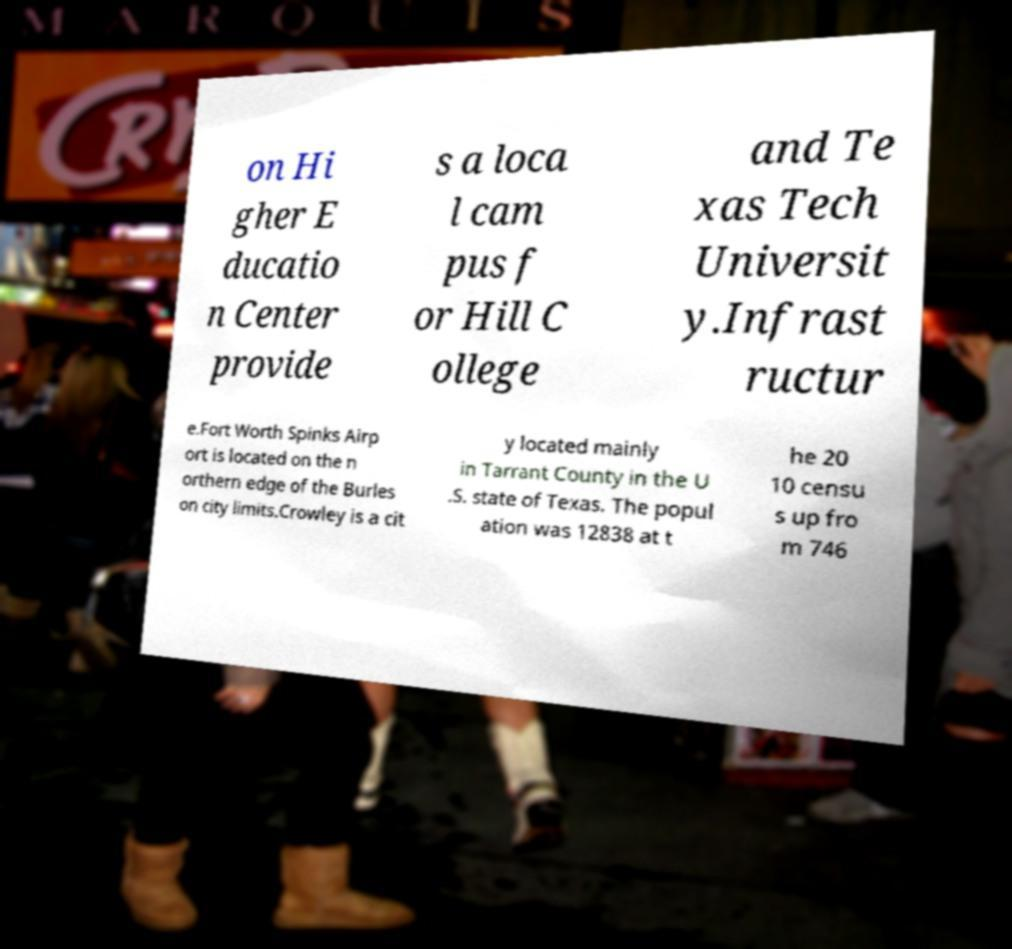Can you read and provide the text displayed in the image?This photo seems to have some interesting text. Can you extract and type it out for me? on Hi gher E ducatio n Center provide s a loca l cam pus f or Hill C ollege and Te xas Tech Universit y.Infrast ructur e.Fort Worth Spinks Airp ort is located on the n orthern edge of the Burles on city limits.Crowley is a cit y located mainly in Tarrant County in the U .S. state of Texas. The popul ation was 12838 at t he 20 10 censu s up fro m 746 